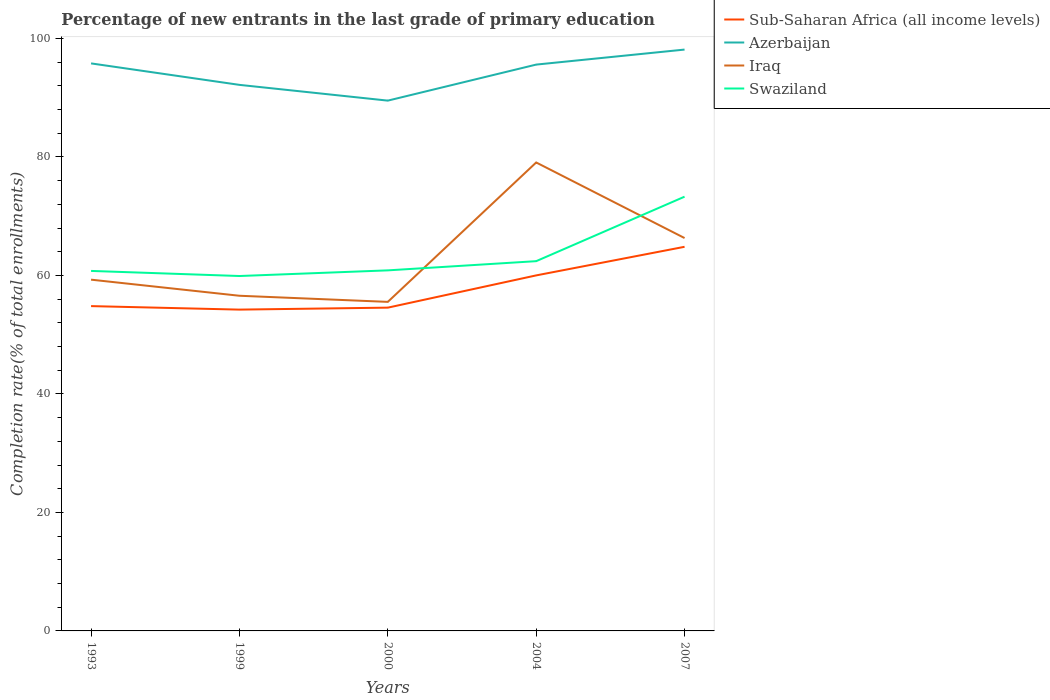How many different coloured lines are there?
Ensure brevity in your answer.  4. Does the line corresponding to Sub-Saharan Africa (all income levels) intersect with the line corresponding to Iraq?
Give a very brief answer. No. Is the number of lines equal to the number of legend labels?
Ensure brevity in your answer.  Yes. Across all years, what is the maximum percentage of new entrants in Azerbaijan?
Make the answer very short. 89.51. In which year was the percentage of new entrants in Azerbaijan maximum?
Provide a succinct answer. 2000. What is the total percentage of new entrants in Iraq in the graph?
Your answer should be compact. 1.03. What is the difference between the highest and the second highest percentage of new entrants in Sub-Saharan Africa (all income levels)?
Offer a terse response. 10.6. What is the difference between the highest and the lowest percentage of new entrants in Iraq?
Keep it short and to the point. 2. Are the values on the major ticks of Y-axis written in scientific E-notation?
Offer a terse response. No. How are the legend labels stacked?
Make the answer very short. Vertical. What is the title of the graph?
Offer a terse response. Percentage of new entrants in the last grade of primary education. What is the label or title of the Y-axis?
Provide a succinct answer. Completion rate(% of total enrollments). What is the Completion rate(% of total enrollments) of Sub-Saharan Africa (all income levels) in 1993?
Your answer should be very brief. 54.83. What is the Completion rate(% of total enrollments) of Azerbaijan in 1993?
Provide a short and direct response. 95.8. What is the Completion rate(% of total enrollments) of Iraq in 1993?
Your response must be concise. 59.29. What is the Completion rate(% of total enrollments) of Swaziland in 1993?
Keep it short and to the point. 60.77. What is the Completion rate(% of total enrollments) of Sub-Saharan Africa (all income levels) in 1999?
Offer a very short reply. 54.24. What is the Completion rate(% of total enrollments) in Azerbaijan in 1999?
Your response must be concise. 92.17. What is the Completion rate(% of total enrollments) of Iraq in 1999?
Your answer should be compact. 56.58. What is the Completion rate(% of total enrollments) in Swaziland in 1999?
Keep it short and to the point. 59.91. What is the Completion rate(% of total enrollments) of Sub-Saharan Africa (all income levels) in 2000?
Provide a succinct answer. 54.57. What is the Completion rate(% of total enrollments) in Azerbaijan in 2000?
Provide a succinct answer. 89.51. What is the Completion rate(% of total enrollments) of Iraq in 2000?
Make the answer very short. 55.54. What is the Completion rate(% of total enrollments) of Swaziland in 2000?
Your answer should be compact. 60.86. What is the Completion rate(% of total enrollments) in Sub-Saharan Africa (all income levels) in 2004?
Offer a terse response. 60.01. What is the Completion rate(% of total enrollments) of Azerbaijan in 2004?
Give a very brief answer. 95.6. What is the Completion rate(% of total enrollments) of Iraq in 2004?
Offer a terse response. 79.07. What is the Completion rate(% of total enrollments) in Swaziland in 2004?
Provide a short and direct response. 62.41. What is the Completion rate(% of total enrollments) of Sub-Saharan Africa (all income levels) in 2007?
Your answer should be compact. 64.84. What is the Completion rate(% of total enrollments) of Azerbaijan in 2007?
Provide a succinct answer. 98.13. What is the Completion rate(% of total enrollments) in Iraq in 2007?
Your answer should be compact. 66.32. What is the Completion rate(% of total enrollments) of Swaziland in 2007?
Provide a short and direct response. 73.3. Across all years, what is the maximum Completion rate(% of total enrollments) in Sub-Saharan Africa (all income levels)?
Provide a succinct answer. 64.84. Across all years, what is the maximum Completion rate(% of total enrollments) in Azerbaijan?
Offer a very short reply. 98.13. Across all years, what is the maximum Completion rate(% of total enrollments) of Iraq?
Keep it short and to the point. 79.07. Across all years, what is the maximum Completion rate(% of total enrollments) of Swaziland?
Make the answer very short. 73.3. Across all years, what is the minimum Completion rate(% of total enrollments) of Sub-Saharan Africa (all income levels)?
Your answer should be very brief. 54.24. Across all years, what is the minimum Completion rate(% of total enrollments) in Azerbaijan?
Give a very brief answer. 89.51. Across all years, what is the minimum Completion rate(% of total enrollments) in Iraq?
Provide a short and direct response. 55.54. Across all years, what is the minimum Completion rate(% of total enrollments) in Swaziland?
Your answer should be compact. 59.91. What is the total Completion rate(% of total enrollments) of Sub-Saharan Africa (all income levels) in the graph?
Your response must be concise. 288.48. What is the total Completion rate(% of total enrollments) of Azerbaijan in the graph?
Ensure brevity in your answer.  471.21. What is the total Completion rate(% of total enrollments) in Iraq in the graph?
Make the answer very short. 316.8. What is the total Completion rate(% of total enrollments) of Swaziland in the graph?
Provide a short and direct response. 317.25. What is the difference between the Completion rate(% of total enrollments) in Sub-Saharan Africa (all income levels) in 1993 and that in 1999?
Make the answer very short. 0.59. What is the difference between the Completion rate(% of total enrollments) in Azerbaijan in 1993 and that in 1999?
Offer a terse response. 3.62. What is the difference between the Completion rate(% of total enrollments) in Iraq in 1993 and that in 1999?
Keep it short and to the point. 2.72. What is the difference between the Completion rate(% of total enrollments) in Swaziland in 1993 and that in 1999?
Your answer should be very brief. 0.86. What is the difference between the Completion rate(% of total enrollments) of Sub-Saharan Africa (all income levels) in 1993 and that in 2000?
Offer a terse response. 0.26. What is the difference between the Completion rate(% of total enrollments) of Azerbaijan in 1993 and that in 2000?
Your answer should be very brief. 6.28. What is the difference between the Completion rate(% of total enrollments) of Iraq in 1993 and that in 2000?
Make the answer very short. 3.75. What is the difference between the Completion rate(% of total enrollments) of Swaziland in 1993 and that in 2000?
Offer a terse response. -0.09. What is the difference between the Completion rate(% of total enrollments) of Sub-Saharan Africa (all income levels) in 1993 and that in 2004?
Your response must be concise. -5.18. What is the difference between the Completion rate(% of total enrollments) in Azerbaijan in 1993 and that in 2004?
Offer a very short reply. 0.2. What is the difference between the Completion rate(% of total enrollments) in Iraq in 1993 and that in 2004?
Provide a short and direct response. -19.78. What is the difference between the Completion rate(% of total enrollments) in Swaziland in 1993 and that in 2004?
Your answer should be very brief. -1.65. What is the difference between the Completion rate(% of total enrollments) of Sub-Saharan Africa (all income levels) in 1993 and that in 2007?
Offer a very short reply. -10.01. What is the difference between the Completion rate(% of total enrollments) of Azerbaijan in 1993 and that in 2007?
Make the answer very short. -2.33. What is the difference between the Completion rate(% of total enrollments) of Iraq in 1993 and that in 2007?
Your answer should be very brief. -7.02. What is the difference between the Completion rate(% of total enrollments) in Swaziland in 1993 and that in 2007?
Make the answer very short. -12.53. What is the difference between the Completion rate(% of total enrollments) of Sub-Saharan Africa (all income levels) in 1999 and that in 2000?
Keep it short and to the point. -0.33. What is the difference between the Completion rate(% of total enrollments) of Azerbaijan in 1999 and that in 2000?
Your answer should be compact. 2.66. What is the difference between the Completion rate(% of total enrollments) of Iraq in 1999 and that in 2000?
Make the answer very short. 1.03. What is the difference between the Completion rate(% of total enrollments) in Swaziland in 1999 and that in 2000?
Your answer should be compact. -0.95. What is the difference between the Completion rate(% of total enrollments) of Sub-Saharan Africa (all income levels) in 1999 and that in 2004?
Provide a succinct answer. -5.78. What is the difference between the Completion rate(% of total enrollments) in Azerbaijan in 1999 and that in 2004?
Make the answer very short. -3.42. What is the difference between the Completion rate(% of total enrollments) in Iraq in 1999 and that in 2004?
Ensure brevity in your answer.  -22.5. What is the difference between the Completion rate(% of total enrollments) in Swaziland in 1999 and that in 2004?
Provide a succinct answer. -2.51. What is the difference between the Completion rate(% of total enrollments) in Sub-Saharan Africa (all income levels) in 1999 and that in 2007?
Ensure brevity in your answer.  -10.6. What is the difference between the Completion rate(% of total enrollments) of Azerbaijan in 1999 and that in 2007?
Your response must be concise. -5.96. What is the difference between the Completion rate(% of total enrollments) of Iraq in 1999 and that in 2007?
Your answer should be compact. -9.74. What is the difference between the Completion rate(% of total enrollments) of Swaziland in 1999 and that in 2007?
Your response must be concise. -13.39. What is the difference between the Completion rate(% of total enrollments) of Sub-Saharan Africa (all income levels) in 2000 and that in 2004?
Ensure brevity in your answer.  -5.44. What is the difference between the Completion rate(% of total enrollments) of Azerbaijan in 2000 and that in 2004?
Your answer should be very brief. -6.08. What is the difference between the Completion rate(% of total enrollments) of Iraq in 2000 and that in 2004?
Your answer should be compact. -23.53. What is the difference between the Completion rate(% of total enrollments) of Swaziland in 2000 and that in 2004?
Offer a very short reply. -1.55. What is the difference between the Completion rate(% of total enrollments) of Sub-Saharan Africa (all income levels) in 2000 and that in 2007?
Offer a terse response. -10.27. What is the difference between the Completion rate(% of total enrollments) of Azerbaijan in 2000 and that in 2007?
Provide a succinct answer. -8.62. What is the difference between the Completion rate(% of total enrollments) in Iraq in 2000 and that in 2007?
Provide a short and direct response. -10.77. What is the difference between the Completion rate(% of total enrollments) of Swaziland in 2000 and that in 2007?
Give a very brief answer. -12.44. What is the difference between the Completion rate(% of total enrollments) in Sub-Saharan Africa (all income levels) in 2004 and that in 2007?
Ensure brevity in your answer.  -4.83. What is the difference between the Completion rate(% of total enrollments) in Azerbaijan in 2004 and that in 2007?
Offer a very short reply. -2.53. What is the difference between the Completion rate(% of total enrollments) in Iraq in 2004 and that in 2007?
Provide a short and direct response. 12.76. What is the difference between the Completion rate(% of total enrollments) of Swaziland in 2004 and that in 2007?
Provide a succinct answer. -10.88. What is the difference between the Completion rate(% of total enrollments) in Sub-Saharan Africa (all income levels) in 1993 and the Completion rate(% of total enrollments) in Azerbaijan in 1999?
Provide a succinct answer. -37.35. What is the difference between the Completion rate(% of total enrollments) in Sub-Saharan Africa (all income levels) in 1993 and the Completion rate(% of total enrollments) in Iraq in 1999?
Ensure brevity in your answer.  -1.75. What is the difference between the Completion rate(% of total enrollments) in Sub-Saharan Africa (all income levels) in 1993 and the Completion rate(% of total enrollments) in Swaziland in 1999?
Offer a terse response. -5.08. What is the difference between the Completion rate(% of total enrollments) in Azerbaijan in 1993 and the Completion rate(% of total enrollments) in Iraq in 1999?
Provide a short and direct response. 39.22. What is the difference between the Completion rate(% of total enrollments) of Azerbaijan in 1993 and the Completion rate(% of total enrollments) of Swaziland in 1999?
Ensure brevity in your answer.  35.89. What is the difference between the Completion rate(% of total enrollments) in Iraq in 1993 and the Completion rate(% of total enrollments) in Swaziland in 1999?
Offer a very short reply. -0.62. What is the difference between the Completion rate(% of total enrollments) in Sub-Saharan Africa (all income levels) in 1993 and the Completion rate(% of total enrollments) in Azerbaijan in 2000?
Offer a very short reply. -34.69. What is the difference between the Completion rate(% of total enrollments) of Sub-Saharan Africa (all income levels) in 1993 and the Completion rate(% of total enrollments) of Iraq in 2000?
Provide a succinct answer. -0.71. What is the difference between the Completion rate(% of total enrollments) of Sub-Saharan Africa (all income levels) in 1993 and the Completion rate(% of total enrollments) of Swaziland in 2000?
Give a very brief answer. -6.03. What is the difference between the Completion rate(% of total enrollments) in Azerbaijan in 1993 and the Completion rate(% of total enrollments) in Iraq in 2000?
Provide a short and direct response. 40.25. What is the difference between the Completion rate(% of total enrollments) of Azerbaijan in 1993 and the Completion rate(% of total enrollments) of Swaziland in 2000?
Provide a short and direct response. 34.94. What is the difference between the Completion rate(% of total enrollments) in Iraq in 1993 and the Completion rate(% of total enrollments) in Swaziland in 2000?
Your response must be concise. -1.57. What is the difference between the Completion rate(% of total enrollments) of Sub-Saharan Africa (all income levels) in 1993 and the Completion rate(% of total enrollments) of Azerbaijan in 2004?
Ensure brevity in your answer.  -40.77. What is the difference between the Completion rate(% of total enrollments) of Sub-Saharan Africa (all income levels) in 1993 and the Completion rate(% of total enrollments) of Iraq in 2004?
Provide a succinct answer. -24.25. What is the difference between the Completion rate(% of total enrollments) of Sub-Saharan Africa (all income levels) in 1993 and the Completion rate(% of total enrollments) of Swaziland in 2004?
Offer a very short reply. -7.59. What is the difference between the Completion rate(% of total enrollments) in Azerbaijan in 1993 and the Completion rate(% of total enrollments) in Iraq in 2004?
Keep it short and to the point. 16.72. What is the difference between the Completion rate(% of total enrollments) of Azerbaijan in 1993 and the Completion rate(% of total enrollments) of Swaziland in 2004?
Ensure brevity in your answer.  33.38. What is the difference between the Completion rate(% of total enrollments) of Iraq in 1993 and the Completion rate(% of total enrollments) of Swaziland in 2004?
Provide a short and direct response. -3.12. What is the difference between the Completion rate(% of total enrollments) in Sub-Saharan Africa (all income levels) in 1993 and the Completion rate(% of total enrollments) in Azerbaijan in 2007?
Keep it short and to the point. -43.3. What is the difference between the Completion rate(% of total enrollments) of Sub-Saharan Africa (all income levels) in 1993 and the Completion rate(% of total enrollments) of Iraq in 2007?
Your answer should be compact. -11.49. What is the difference between the Completion rate(% of total enrollments) of Sub-Saharan Africa (all income levels) in 1993 and the Completion rate(% of total enrollments) of Swaziland in 2007?
Provide a succinct answer. -18.47. What is the difference between the Completion rate(% of total enrollments) in Azerbaijan in 1993 and the Completion rate(% of total enrollments) in Iraq in 2007?
Your answer should be very brief. 29.48. What is the difference between the Completion rate(% of total enrollments) in Azerbaijan in 1993 and the Completion rate(% of total enrollments) in Swaziland in 2007?
Your answer should be compact. 22.5. What is the difference between the Completion rate(% of total enrollments) in Iraq in 1993 and the Completion rate(% of total enrollments) in Swaziland in 2007?
Give a very brief answer. -14.01. What is the difference between the Completion rate(% of total enrollments) of Sub-Saharan Africa (all income levels) in 1999 and the Completion rate(% of total enrollments) of Azerbaijan in 2000?
Your answer should be very brief. -35.28. What is the difference between the Completion rate(% of total enrollments) of Sub-Saharan Africa (all income levels) in 1999 and the Completion rate(% of total enrollments) of Iraq in 2000?
Give a very brief answer. -1.31. What is the difference between the Completion rate(% of total enrollments) in Sub-Saharan Africa (all income levels) in 1999 and the Completion rate(% of total enrollments) in Swaziland in 2000?
Your answer should be very brief. -6.63. What is the difference between the Completion rate(% of total enrollments) of Azerbaijan in 1999 and the Completion rate(% of total enrollments) of Iraq in 2000?
Provide a succinct answer. 36.63. What is the difference between the Completion rate(% of total enrollments) of Azerbaijan in 1999 and the Completion rate(% of total enrollments) of Swaziland in 2000?
Ensure brevity in your answer.  31.31. What is the difference between the Completion rate(% of total enrollments) in Iraq in 1999 and the Completion rate(% of total enrollments) in Swaziland in 2000?
Offer a very short reply. -4.29. What is the difference between the Completion rate(% of total enrollments) in Sub-Saharan Africa (all income levels) in 1999 and the Completion rate(% of total enrollments) in Azerbaijan in 2004?
Offer a very short reply. -41.36. What is the difference between the Completion rate(% of total enrollments) of Sub-Saharan Africa (all income levels) in 1999 and the Completion rate(% of total enrollments) of Iraq in 2004?
Your answer should be compact. -24.84. What is the difference between the Completion rate(% of total enrollments) in Sub-Saharan Africa (all income levels) in 1999 and the Completion rate(% of total enrollments) in Swaziland in 2004?
Keep it short and to the point. -8.18. What is the difference between the Completion rate(% of total enrollments) of Azerbaijan in 1999 and the Completion rate(% of total enrollments) of Iraq in 2004?
Ensure brevity in your answer.  13.1. What is the difference between the Completion rate(% of total enrollments) in Azerbaijan in 1999 and the Completion rate(% of total enrollments) in Swaziland in 2004?
Offer a terse response. 29.76. What is the difference between the Completion rate(% of total enrollments) of Iraq in 1999 and the Completion rate(% of total enrollments) of Swaziland in 2004?
Make the answer very short. -5.84. What is the difference between the Completion rate(% of total enrollments) in Sub-Saharan Africa (all income levels) in 1999 and the Completion rate(% of total enrollments) in Azerbaijan in 2007?
Your answer should be compact. -43.89. What is the difference between the Completion rate(% of total enrollments) of Sub-Saharan Africa (all income levels) in 1999 and the Completion rate(% of total enrollments) of Iraq in 2007?
Your answer should be compact. -12.08. What is the difference between the Completion rate(% of total enrollments) in Sub-Saharan Africa (all income levels) in 1999 and the Completion rate(% of total enrollments) in Swaziland in 2007?
Your answer should be very brief. -19.06. What is the difference between the Completion rate(% of total enrollments) in Azerbaijan in 1999 and the Completion rate(% of total enrollments) in Iraq in 2007?
Offer a terse response. 25.86. What is the difference between the Completion rate(% of total enrollments) in Azerbaijan in 1999 and the Completion rate(% of total enrollments) in Swaziland in 2007?
Your answer should be very brief. 18.87. What is the difference between the Completion rate(% of total enrollments) of Iraq in 1999 and the Completion rate(% of total enrollments) of Swaziland in 2007?
Provide a succinct answer. -16.72. What is the difference between the Completion rate(% of total enrollments) in Sub-Saharan Africa (all income levels) in 2000 and the Completion rate(% of total enrollments) in Azerbaijan in 2004?
Give a very brief answer. -41.03. What is the difference between the Completion rate(% of total enrollments) in Sub-Saharan Africa (all income levels) in 2000 and the Completion rate(% of total enrollments) in Iraq in 2004?
Provide a succinct answer. -24.51. What is the difference between the Completion rate(% of total enrollments) of Sub-Saharan Africa (all income levels) in 2000 and the Completion rate(% of total enrollments) of Swaziland in 2004?
Your answer should be compact. -7.85. What is the difference between the Completion rate(% of total enrollments) in Azerbaijan in 2000 and the Completion rate(% of total enrollments) in Iraq in 2004?
Offer a very short reply. 10.44. What is the difference between the Completion rate(% of total enrollments) of Azerbaijan in 2000 and the Completion rate(% of total enrollments) of Swaziland in 2004?
Offer a very short reply. 27.1. What is the difference between the Completion rate(% of total enrollments) in Iraq in 2000 and the Completion rate(% of total enrollments) in Swaziland in 2004?
Make the answer very short. -6.87. What is the difference between the Completion rate(% of total enrollments) of Sub-Saharan Africa (all income levels) in 2000 and the Completion rate(% of total enrollments) of Azerbaijan in 2007?
Give a very brief answer. -43.56. What is the difference between the Completion rate(% of total enrollments) in Sub-Saharan Africa (all income levels) in 2000 and the Completion rate(% of total enrollments) in Iraq in 2007?
Your answer should be very brief. -11.75. What is the difference between the Completion rate(% of total enrollments) in Sub-Saharan Africa (all income levels) in 2000 and the Completion rate(% of total enrollments) in Swaziland in 2007?
Your answer should be very brief. -18.73. What is the difference between the Completion rate(% of total enrollments) of Azerbaijan in 2000 and the Completion rate(% of total enrollments) of Iraq in 2007?
Offer a terse response. 23.2. What is the difference between the Completion rate(% of total enrollments) of Azerbaijan in 2000 and the Completion rate(% of total enrollments) of Swaziland in 2007?
Provide a short and direct response. 16.21. What is the difference between the Completion rate(% of total enrollments) of Iraq in 2000 and the Completion rate(% of total enrollments) of Swaziland in 2007?
Provide a succinct answer. -17.76. What is the difference between the Completion rate(% of total enrollments) in Sub-Saharan Africa (all income levels) in 2004 and the Completion rate(% of total enrollments) in Azerbaijan in 2007?
Your answer should be very brief. -38.12. What is the difference between the Completion rate(% of total enrollments) in Sub-Saharan Africa (all income levels) in 2004 and the Completion rate(% of total enrollments) in Iraq in 2007?
Offer a terse response. -6.31. What is the difference between the Completion rate(% of total enrollments) of Sub-Saharan Africa (all income levels) in 2004 and the Completion rate(% of total enrollments) of Swaziland in 2007?
Give a very brief answer. -13.29. What is the difference between the Completion rate(% of total enrollments) of Azerbaijan in 2004 and the Completion rate(% of total enrollments) of Iraq in 2007?
Give a very brief answer. 29.28. What is the difference between the Completion rate(% of total enrollments) of Azerbaijan in 2004 and the Completion rate(% of total enrollments) of Swaziland in 2007?
Offer a very short reply. 22.3. What is the difference between the Completion rate(% of total enrollments) of Iraq in 2004 and the Completion rate(% of total enrollments) of Swaziland in 2007?
Your answer should be very brief. 5.77. What is the average Completion rate(% of total enrollments) of Sub-Saharan Africa (all income levels) per year?
Ensure brevity in your answer.  57.7. What is the average Completion rate(% of total enrollments) of Azerbaijan per year?
Make the answer very short. 94.24. What is the average Completion rate(% of total enrollments) of Iraq per year?
Make the answer very short. 63.36. What is the average Completion rate(% of total enrollments) of Swaziland per year?
Your answer should be compact. 63.45. In the year 1993, what is the difference between the Completion rate(% of total enrollments) in Sub-Saharan Africa (all income levels) and Completion rate(% of total enrollments) in Azerbaijan?
Your response must be concise. -40.97. In the year 1993, what is the difference between the Completion rate(% of total enrollments) of Sub-Saharan Africa (all income levels) and Completion rate(% of total enrollments) of Iraq?
Make the answer very short. -4.46. In the year 1993, what is the difference between the Completion rate(% of total enrollments) of Sub-Saharan Africa (all income levels) and Completion rate(% of total enrollments) of Swaziland?
Provide a short and direct response. -5.94. In the year 1993, what is the difference between the Completion rate(% of total enrollments) of Azerbaijan and Completion rate(% of total enrollments) of Iraq?
Your answer should be compact. 36.5. In the year 1993, what is the difference between the Completion rate(% of total enrollments) in Azerbaijan and Completion rate(% of total enrollments) in Swaziland?
Your answer should be compact. 35.03. In the year 1993, what is the difference between the Completion rate(% of total enrollments) of Iraq and Completion rate(% of total enrollments) of Swaziland?
Give a very brief answer. -1.47. In the year 1999, what is the difference between the Completion rate(% of total enrollments) of Sub-Saharan Africa (all income levels) and Completion rate(% of total enrollments) of Azerbaijan?
Provide a short and direct response. -37.94. In the year 1999, what is the difference between the Completion rate(% of total enrollments) of Sub-Saharan Africa (all income levels) and Completion rate(% of total enrollments) of Iraq?
Make the answer very short. -2.34. In the year 1999, what is the difference between the Completion rate(% of total enrollments) of Sub-Saharan Africa (all income levels) and Completion rate(% of total enrollments) of Swaziland?
Make the answer very short. -5.67. In the year 1999, what is the difference between the Completion rate(% of total enrollments) in Azerbaijan and Completion rate(% of total enrollments) in Iraq?
Give a very brief answer. 35.6. In the year 1999, what is the difference between the Completion rate(% of total enrollments) of Azerbaijan and Completion rate(% of total enrollments) of Swaziland?
Offer a terse response. 32.26. In the year 1999, what is the difference between the Completion rate(% of total enrollments) in Iraq and Completion rate(% of total enrollments) in Swaziland?
Make the answer very short. -3.33. In the year 2000, what is the difference between the Completion rate(% of total enrollments) in Sub-Saharan Africa (all income levels) and Completion rate(% of total enrollments) in Azerbaijan?
Your answer should be compact. -34.94. In the year 2000, what is the difference between the Completion rate(% of total enrollments) in Sub-Saharan Africa (all income levels) and Completion rate(% of total enrollments) in Iraq?
Your response must be concise. -0.97. In the year 2000, what is the difference between the Completion rate(% of total enrollments) of Sub-Saharan Africa (all income levels) and Completion rate(% of total enrollments) of Swaziland?
Keep it short and to the point. -6.29. In the year 2000, what is the difference between the Completion rate(% of total enrollments) in Azerbaijan and Completion rate(% of total enrollments) in Iraq?
Give a very brief answer. 33.97. In the year 2000, what is the difference between the Completion rate(% of total enrollments) of Azerbaijan and Completion rate(% of total enrollments) of Swaziland?
Provide a succinct answer. 28.65. In the year 2000, what is the difference between the Completion rate(% of total enrollments) of Iraq and Completion rate(% of total enrollments) of Swaziland?
Make the answer very short. -5.32. In the year 2004, what is the difference between the Completion rate(% of total enrollments) in Sub-Saharan Africa (all income levels) and Completion rate(% of total enrollments) in Azerbaijan?
Offer a terse response. -35.58. In the year 2004, what is the difference between the Completion rate(% of total enrollments) of Sub-Saharan Africa (all income levels) and Completion rate(% of total enrollments) of Iraq?
Your answer should be compact. -19.06. In the year 2004, what is the difference between the Completion rate(% of total enrollments) of Sub-Saharan Africa (all income levels) and Completion rate(% of total enrollments) of Swaziland?
Your answer should be very brief. -2.4. In the year 2004, what is the difference between the Completion rate(% of total enrollments) in Azerbaijan and Completion rate(% of total enrollments) in Iraq?
Your answer should be very brief. 16.52. In the year 2004, what is the difference between the Completion rate(% of total enrollments) in Azerbaijan and Completion rate(% of total enrollments) in Swaziland?
Your response must be concise. 33.18. In the year 2004, what is the difference between the Completion rate(% of total enrollments) of Iraq and Completion rate(% of total enrollments) of Swaziland?
Your answer should be compact. 16.66. In the year 2007, what is the difference between the Completion rate(% of total enrollments) in Sub-Saharan Africa (all income levels) and Completion rate(% of total enrollments) in Azerbaijan?
Give a very brief answer. -33.29. In the year 2007, what is the difference between the Completion rate(% of total enrollments) in Sub-Saharan Africa (all income levels) and Completion rate(% of total enrollments) in Iraq?
Your answer should be very brief. -1.48. In the year 2007, what is the difference between the Completion rate(% of total enrollments) of Sub-Saharan Africa (all income levels) and Completion rate(% of total enrollments) of Swaziland?
Provide a succinct answer. -8.46. In the year 2007, what is the difference between the Completion rate(% of total enrollments) in Azerbaijan and Completion rate(% of total enrollments) in Iraq?
Ensure brevity in your answer.  31.81. In the year 2007, what is the difference between the Completion rate(% of total enrollments) in Azerbaijan and Completion rate(% of total enrollments) in Swaziland?
Offer a very short reply. 24.83. In the year 2007, what is the difference between the Completion rate(% of total enrollments) in Iraq and Completion rate(% of total enrollments) in Swaziland?
Ensure brevity in your answer.  -6.98. What is the ratio of the Completion rate(% of total enrollments) of Sub-Saharan Africa (all income levels) in 1993 to that in 1999?
Your answer should be very brief. 1.01. What is the ratio of the Completion rate(% of total enrollments) in Azerbaijan in 1993 to that in 1999?
Your response must be concise. 1.04. What is the ratio of the Completion rate(% of total enrollments) in Iraq in 1993 to that in 1999?
Your answer should be compact. 1.05. What is the ratio of the Completion rate(% of total enrollments) of Swaziland in 1993 to that in 1999?
Your response must be concise. 1.01. What is the ratio of the Completion rate(% of total enrollments) in Azerbaijan in 1993 to that in 2000?
Provide a short and direct response. 1.07. What is the ratio of the Completion rate(% of total enrollments) in Iraq in 1993 to that in 2000?
Your answer should be very brief. 1.07. What is the ratio of the Completion rate(% of total enrollments) of Sub-Saharan Africa (all income levels) in 1993 to that in 2004?
Provide a succinct answer. 0.91. What is the ratio of the Completion rate(% of total enrollments) of Iraq in 1993 to that in 2004?
Your answer should be very brief. 0.75. What is the ratio of the Completion rate(% of total enrollments) of Swaziland in 1993 to that in 2004?
Give a very brief answer. 0.97. What is the ratio of the Completion rate(% of total enrollments) of Sub-Saharan Africa (all income levels) in 1993 to that in 2007?
Give a very brief answer. 0.85. What is the ratio of the Completion rate(% of total enrollments) of Azerbaijan in 1993 to that in 2007?
Provide a succinct answer. 0.98. What is the ratio of the Completion rate(% of total enrollments) in Iraq in 1993 to that in 2007?
Provide a succinct answer. 0.89. What is the ratio of the Completion rate(% of total enrollments) in Swaziland in 1993 to that in 2007?
Give a very brief answer. 0.83. What is the ratio of the Completion rate(% of total enrollments) of Sub-Saharan Africa (all income levels) in 1999 to that in 2000?
Your response must be concise. 0.99. What is the ratio of the Completion rate(% of total enrollments) in Azerbaijan in 1999 to that in 2000?
Your answer should be compact. 1.03. What is the ratio of the Completion rate(% of total enrollments) of Iraq in 1999 to that in 2000?
Make the answer very short. 1.02. What is the ratio of the Completion rate(% of total enrollments) in Swaziland in 1999 to that in 2000?
Provide a short and direct response. 0.98. What is the ratio of the Completion rate(% of total enrollments) of Sub-Saharan Africa (all income levels) in 1999 to that in 2004?
Make the answer very short. 0.9. What is the ratio of the Completion rate(% of total enrollments) of Azerbaijan in 1999 to that in 2004?
Your answer should be very brief. 0.96. What is the ratio of the Completion rate(% of total enrollments) of Iraq in 1999 to that in 2004?
Offer a very short reply. 0.72. What is the ratio of the Completion rate(% of total enrollments) in Swaziland in 1999 to that in 2004?
Keep it short and to the point. 0.96. What is the ratio of the Completion rate(% of total enrollments) in Sub-Saharan Africa (all income levels) in 1999 to that in 2007?
Offer a terse response. 0.84. What is the ratio of the Completion rate(% of total enrollments) in Azerbaijan in 1999 to that in 2007?
Give a very brief answer. 0.94. What is the ratio of the Completion rate(% of total enrollments) in Iraq in 1999 to that in 2007?
Provide a succinct answer. 0.85. What is the ratio of the Completion rate(% of total enrollments) of Swaziland in 1999 to that in 2007?
Offer a terse response. 0.82. What is the ratio of the Completion rate(% of total enrollments) of Sub-Saharan Africa (all income levels) in 2000 to that in 2004?
Provide a succinct answer. 0.91. What is the ratio of the Completion rate(% of total enrollments) of Azerbaijan in 2000 to that in 2004?
Offer a terse response. 0.94. What is the ratio of the Completion rate(% of total enrollments) of Iraq in 2000 to that in 2004?
Provide a succinct answer. 0.7. What is the ratio of the Completion rate(% of total enrollments) in Swaziland in 2000 to that in 2004?
Your answer should be compact. 0.98. What is the ratio of the Completion rate(% of total enrollments) of Sub-Saharan Africa (all income levels) in 2000 to that in 2007?
Give a very brief answer. 0.84. What is the ratio of the Completion rate(% of total enrollments) of Azerbaijan in 2000 to that in 2007?
Give a very brief answer. 0.91. What is the ratio of the Completion rate(% of total enrollments) in Iraq in 2000 to that in 2007?
Give a very brief answer. 0.84. What is the ratio of the Completion rate(% of total enrollments) of Swaziland in 2000 to that in 2007?
Give a very brief answer. 0.83. What is the ratio of the Completion rate(% of total enrollments) of Sub-Saharan Africa (all income levels) in 2004 to that in 2007?
Your response must be concise. 0.93. What is the ratio of the Completion rate(% of total enrollments) in Azerbaijan in 2004 to that in 2007?
Give a very brief answer. 0.97. What is the ratio of the Completion rate(% of total enrollments) of Iraq in 2004 to that in 2007?
Your answer should be compact. 1.19. What is the ratio of the Completion rate(% of total enrollments) of Swaziland in 2004 to that in 2007?
Make the answer very short. 0.85. What is the difference between the highest and the second highest Completion rate(% of total enrollments) in Sub-Saharan Africa (all income levels)?
Ensure brevity in your answer.  4.83. What is the difference between the highest and the second highest Completion rate(% of total enrollments) of Azerbaijan?
Offer a very short reply. 2.33. What is the difference between the highest and the second highest Completion rate(% of total enrollments) of Iraq?
Give a very brief answer. 12.76. What is the difference between the highest and the second highest Completion rate(% of total enrollments) of Swaziland?
Your response must be concise. 10.88. What is the difference between the highest and the lowest Completion rate(% of total enrollments) in Sub-Saharan Africa (all income levels)?
Ensure brevity in your answer.  10.6. What is the difference between the highest and the lowest Completion rate(% of total enrollments) in Azerbaijan?
Make the answer very short. 8.62. What is the difference between the highest and the lowest Completion rate(% of total enrollments) of Iraq?
Provide a succinct answer. 23.53. What is the difference between the highest and the lowest Completion rate(% of total enrollments) of Swaziland?
Provide a short and direct response. 13.39. 